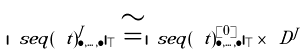Convert formula to latex. <formula><loc_0><loc_0><loc_500><loc_500>| \ s e q ( \ t ) ^ { J } _ { \bullet , \dots , \bullet } | _ { \top } \cong | \ s e q ( \ t ) ^ { [ 0 ] } _ { \bullet , \dots , \bullet } | _ { \top } \times \ D ^ { J }</formula> 